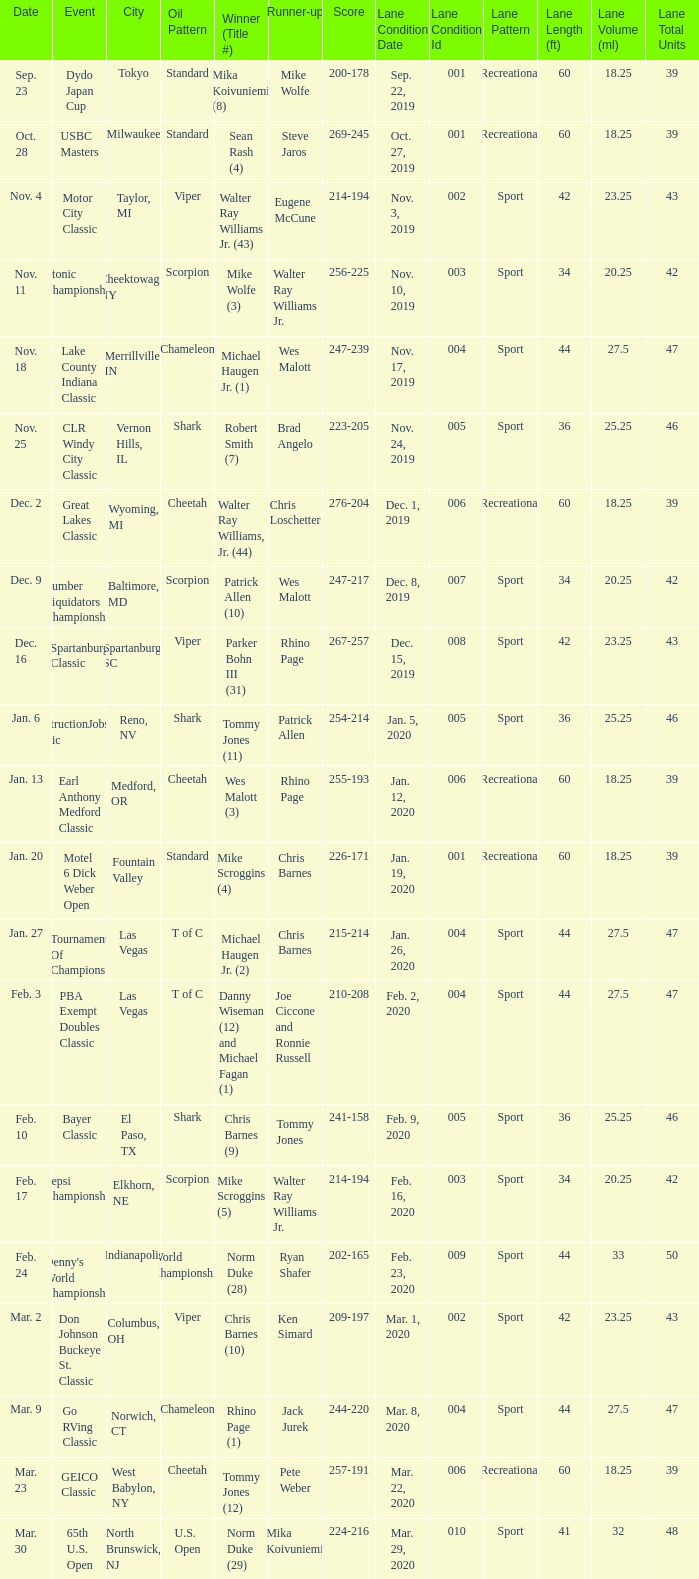Which Score has an Event of constructionjobs.com classic? 254-214. 